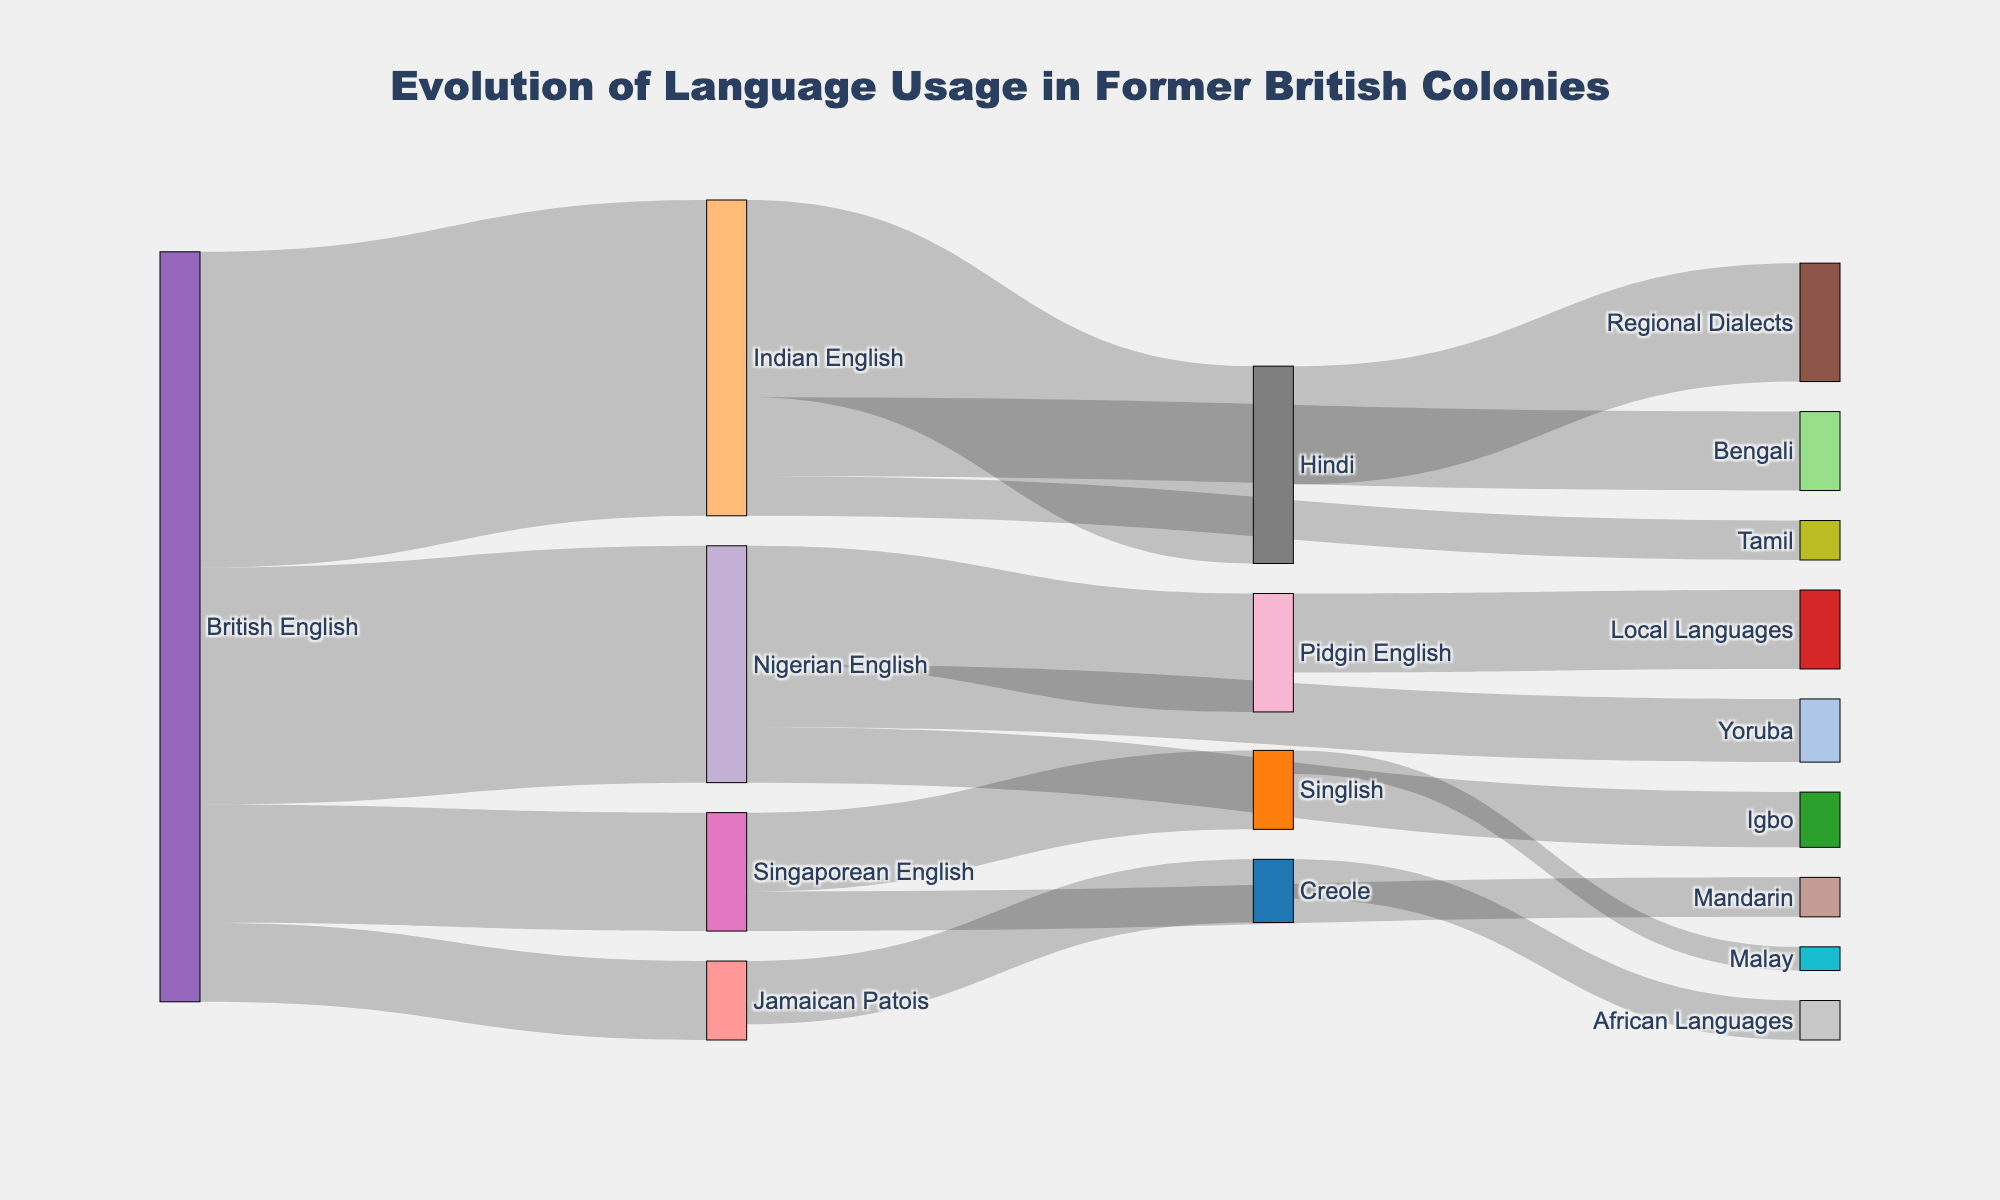what is the most common 'Source' node? The British English node has the most connections to various target nodes. There are four connections from British English to other languages, which are Nigerian English, Indian English, Singaporean English, and Jamaican Patois. By counting the 'Source' nodes, it is clear that British English appears the most frequently.
Answer: British English What is the title of the figure? The title of the figure is prominently displayed at the top and reads "Evolution of Language Usage in Former British Colonies". This provides the context of the visual representation.
Answer: Evolution of Language Usage in Former British Colonies Which language transitions to the most target languages? Indian English makes transitions to three target languages: Hindi, Bengali, and Tamil. This is the largest number of transitions from any one source language.
Answer: Indian English What is the total flow value from British English? To find the total flow value from British English, you sum the values of its transitions: 30 (to Nigerian English) + 40 (to Indian English) + 15 (to Singaporean English) + 10 (to Jamaican Patois) = 95.
Answer: 95 How does the flow value from Nigerian English compare to British English? The total flow value from Nigerian English is 30 (to Pidgin English, Yoruba, and Igbo) while British English has a total flow value of 95. By comparing, we can see that British English has a significantly higher total flow value than Nigerian English.
Answer: Nigerian English has a lower flow value Which language transition has the smallest value? The transition from Singlish to Malay has the smallest flow value of 3. This value is easily identifiable as the smallest number in the dataset.
Answer: Singlish to Malay How many different languages does Singlish transition to? Singlish transitions to only one other language, which is Malay. This can be observed directly from the Sankey diagram.
Answer: 1 Which language transitions lead to Creole? Jamaican Patois transitions to Creole. This information is directly shown by one of the connecting lines in the diagram.
Answer: Jamaican Patois What is the value of the transition from Indian English to Hindi? The value is explicitly stated in the dataset and visualized as 25.
Answer: 25 